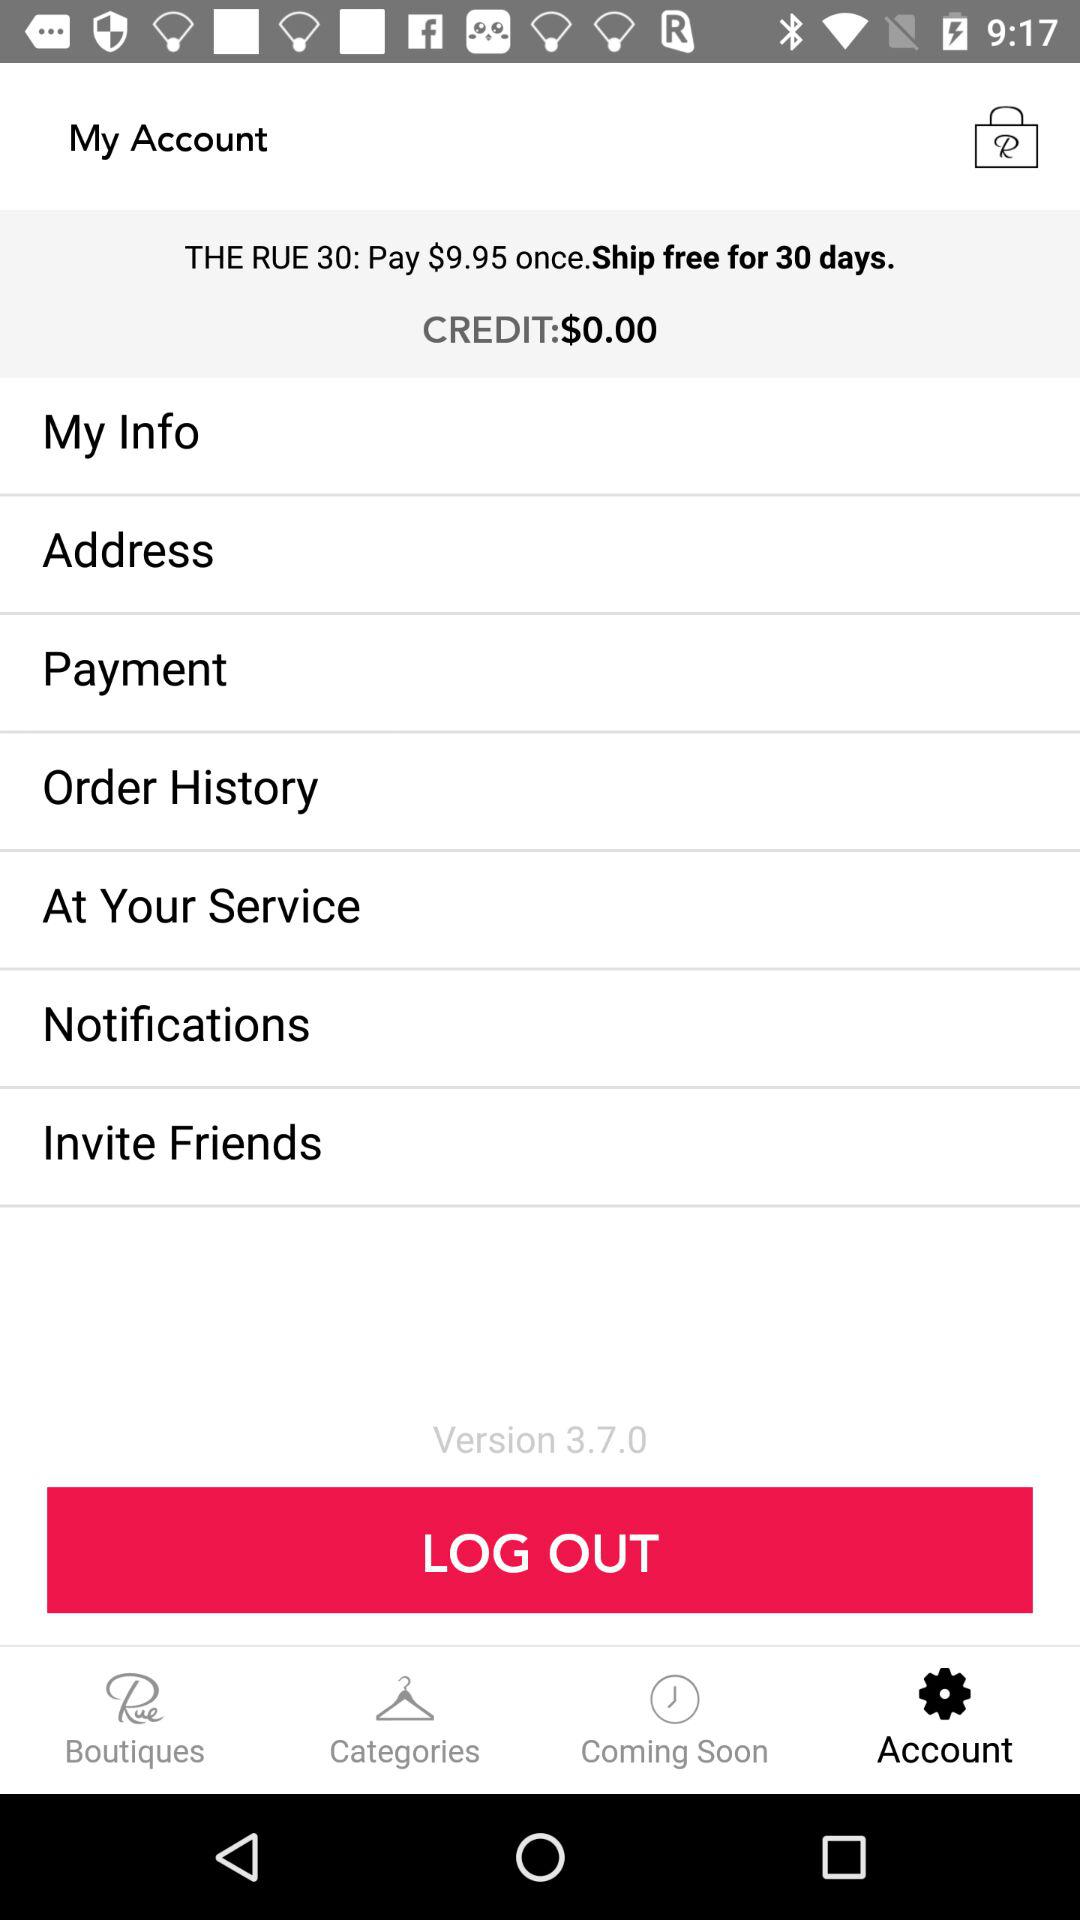How many items are in the cart?
When the provided information is insufficient, respond with <no answer>. <no answer> 